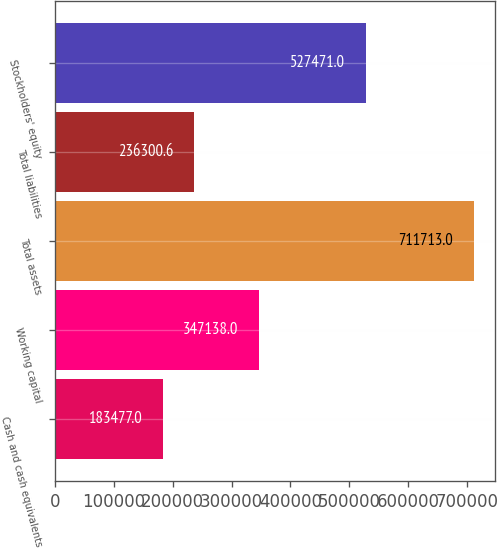Convert chart. <chart><loc_0><loc_0><loc_500><loc_500><bar_chart><fcel>Cash and cash equivalents<fcel>Working capital<fcel>Total assets<fcel>Total liabilities<fcel>Stockholders' equity<nl><fcel>183477<fcel>347138<fcel>711713<fcel>236301<fcel>527471<nl></chart> 